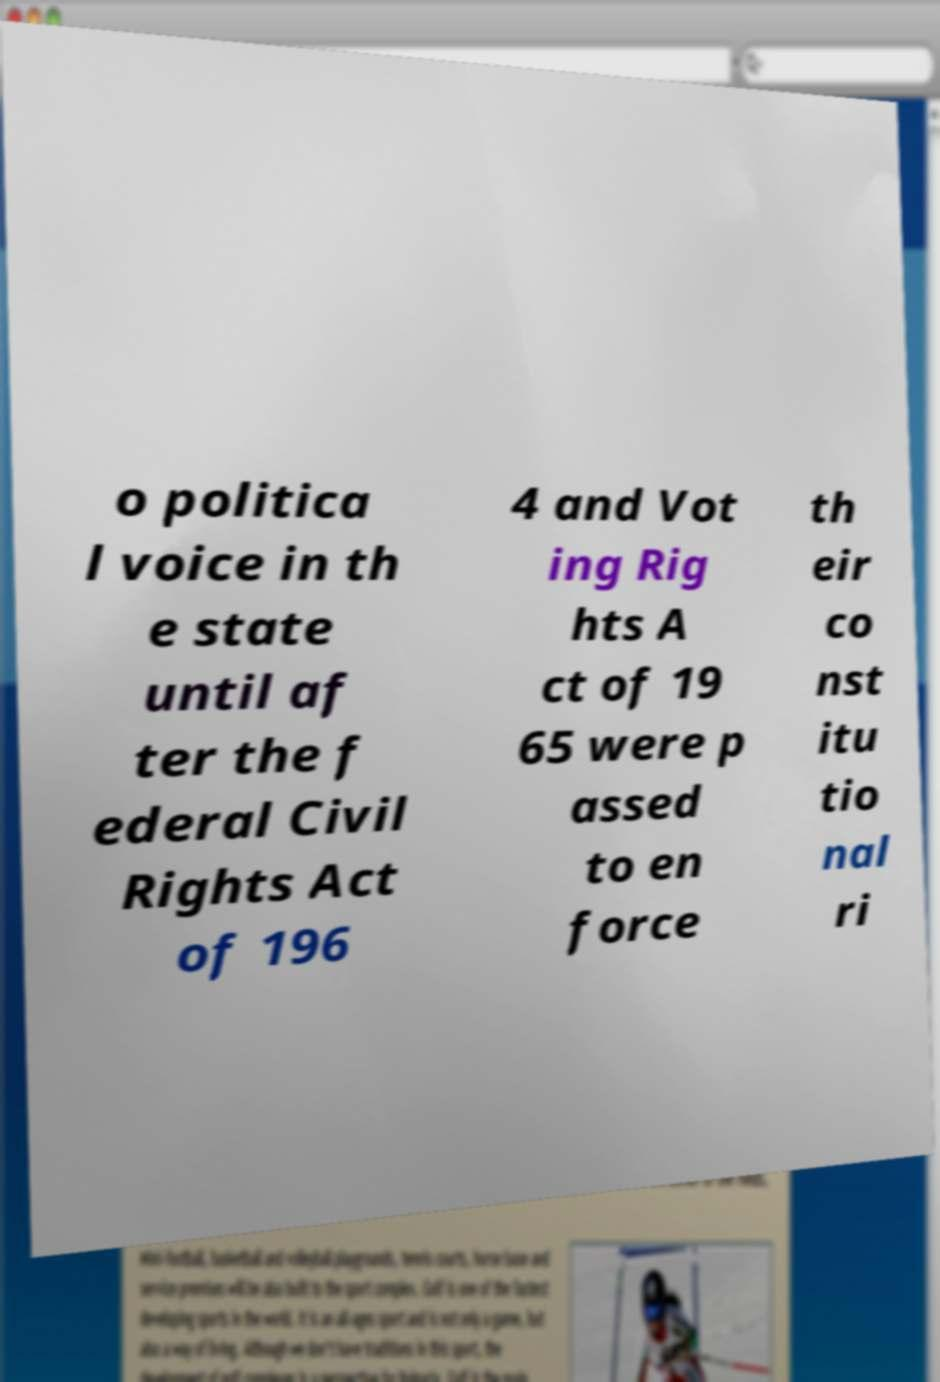Please read and relay the text visible in this image. What does it say? o politica l voice in th e state until af ter the f ederal Civil Rights Act of 196 4 and Vot ing Rig hts A ct of 19 65 were p assed to en force th eir co nst itu tio nal ri 